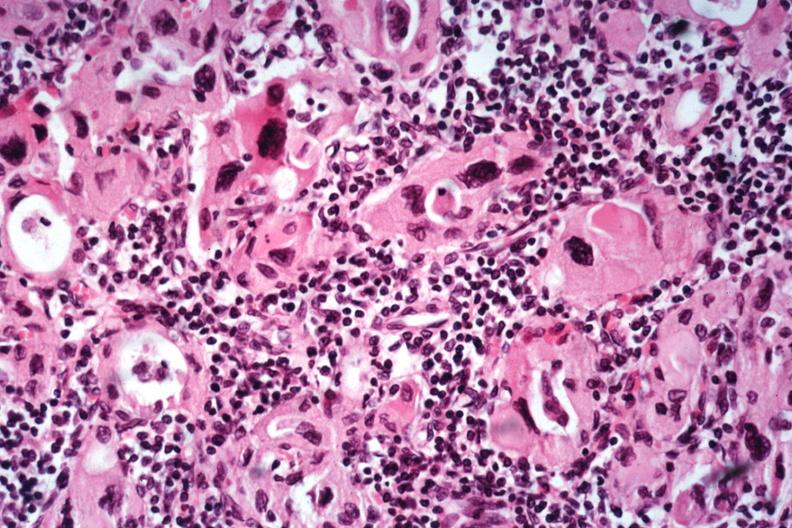does this image show excellent example lymphocytes and hurthle like cells no recognizable thyroid tissue?
Answer the question using a single word or phrase. Yes 